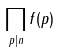Convert formula to latex. <formula><loc_0><loc_0><loc_500><loc_500>\prod _ { p | n } f ( p )</formula> 